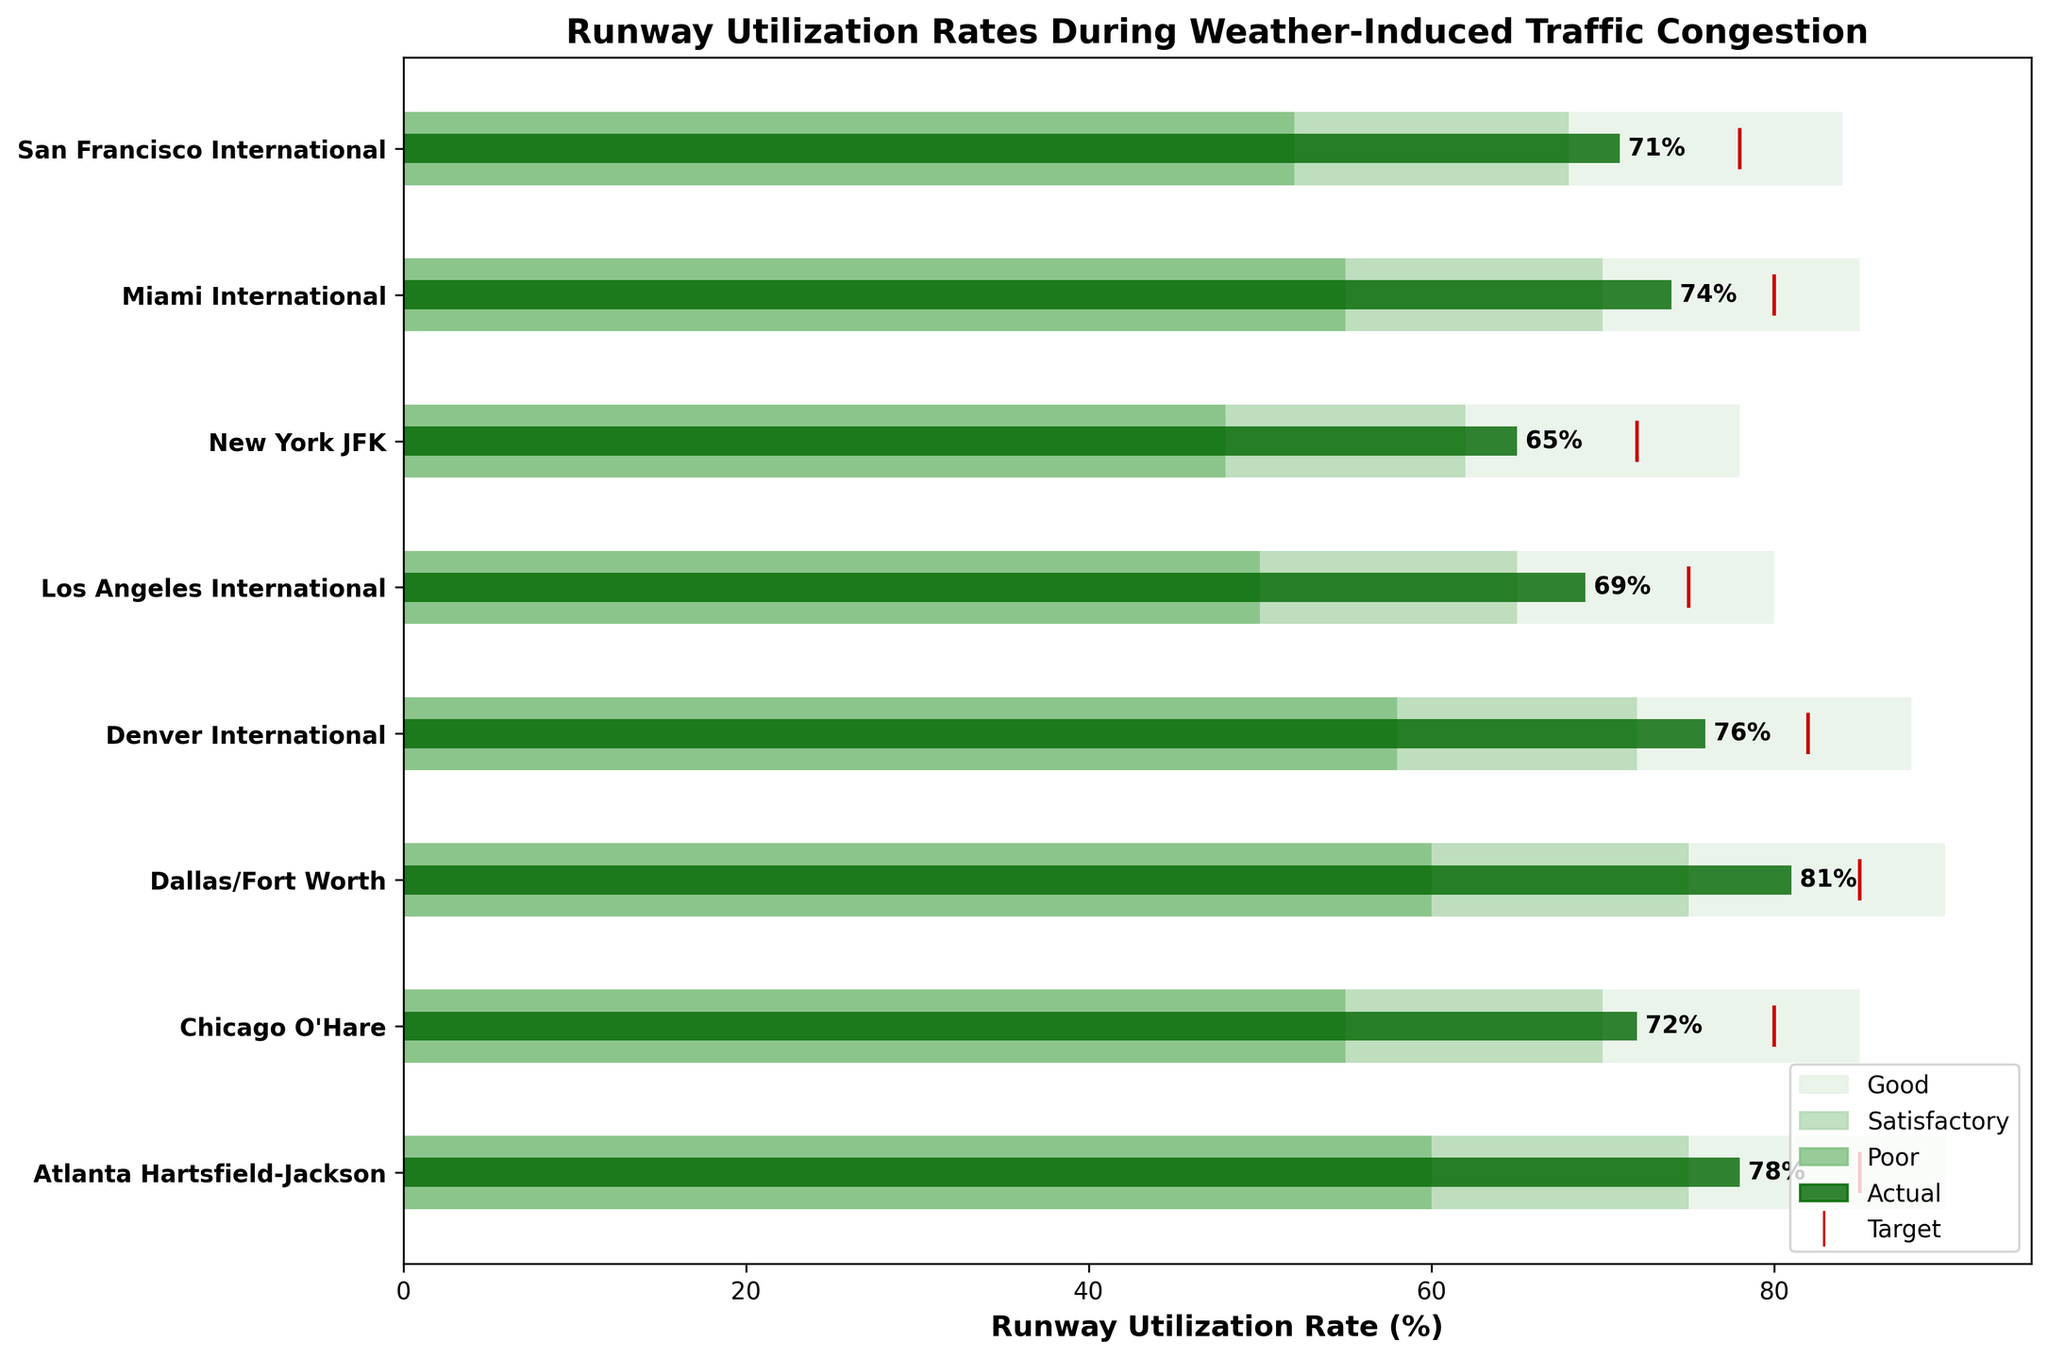what is the title of the plot? The title is displayed at the top of the figure and provides an overview of what the plot represents. In this case, it reads "Runway Utilization Rates During Weather-Induced Traffic Congestion."
Answer: Runway Utilization Rates During Weather-Induced Traffic Congestion Which airport has the highest actual runway utilization rate? The green bar represents the actual runway utilization rate for each airport. By comparing the lengths of each green bar, the longest one belongs to Dallas/Fort Worth with an actual rate of 81%.
Answer: Dallas/Fort Worth Are any of the airports exceeding their target utilization rate? To answer this, we need to compare the green bars (actual rates) with the red markers (target rates). None of the actual rates surpass the target rates marked by the red vertical lines.
Answer: No For Chicago O'Hare, what's the difference between the target and actual utilization rates? The target rate for Chicago O'Hare is represented by the red marker and is 80%. The actual rate (green bar) is 72%. The difference is 80% - 72% = 8%.
Answer: 8% Which airports fall into the 'Poor' category for runway utilization? The 'Poor' category is represented by the darkest green background bar coverage. By inspecting these bars, the actual utilization rates of New York JFK (65%) and Los Angeles International (69%) fall within the 'Poor' category.
Answer: New York JFK, Los Angeles International How many airports are depicted in the chart? Looking at the y-axis labels, each represents an airport. By counting these labels, we can see that there are eight airports listed.
Answer: 8 What is the utilization rate difference between Dallas/Fort Worth and Miami International? The actual utilization rate for Dallas/Fort Worth is 81%, and for Miami International, it is 74%. The difference is 81% - 74% = 7%.
Answer: 7% Which airport has the lowest actual utilization rate and what is it? By comparing the lengths of the green bars, the shortest one belongs to New York JFK with an actual rate of 65%.
Answer: New York JFK, 65% Do any airports achieve at least a 'Satisfactory' utilization rate? The 'Satisfactory' category is represented by the middle green background bar coverage. By comparing the actual utilization rates, airports such as Atlanta Hartsfield-Jackson, Chicago O'Hare, Dallas/Fort Worth, Denver International, and Miami International achieve at least a 'Satisfactory' rate lying within this range.
Answer: Yes Which airports have actual utilization rates that fall within the 'Good' range? The 'Good' category is represented by the lightest green background bar. By comparing the actual utilization rates with this range, no airports' actual rates fall within the 'Good' range based on the figure.
Answer: None 